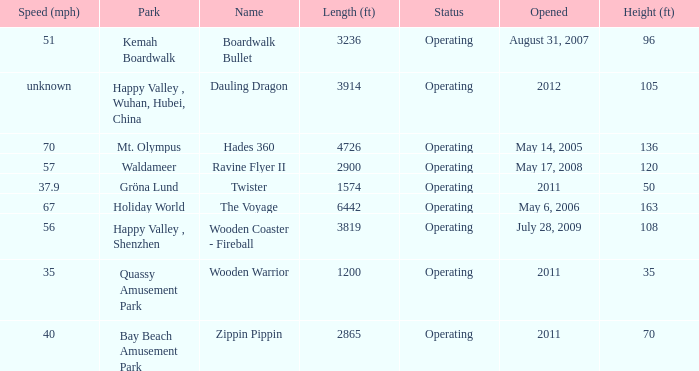How many parks is Zippin Pippin located in 1.0. 